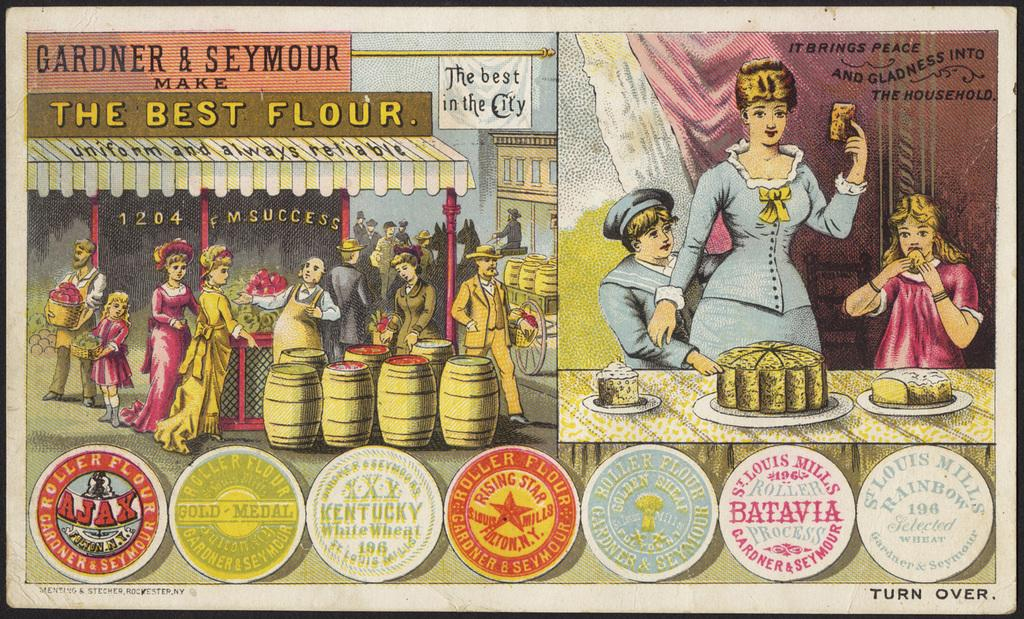<image>
Create a compact narrative representing the image presented. A old looking ad with thing like Ajax and flour on it. 